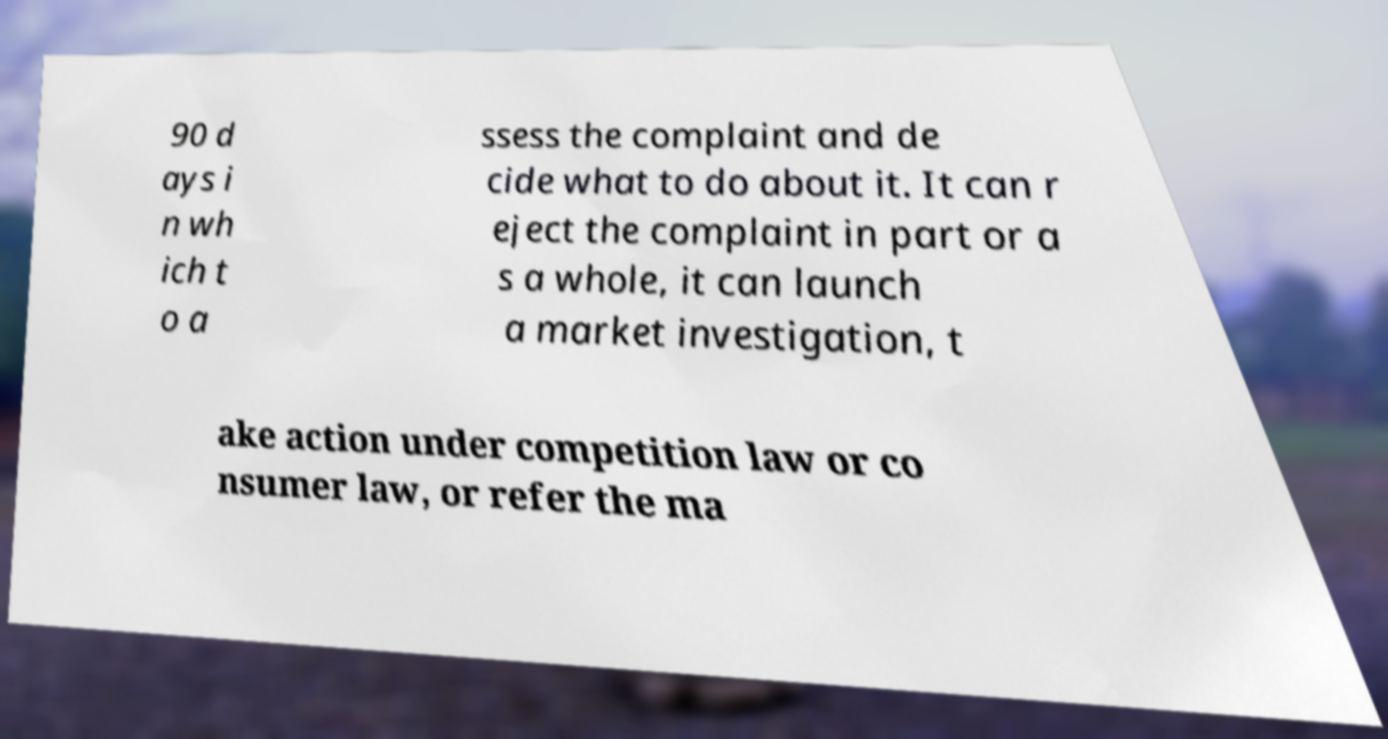There's text embedded in this image that I need extracted. Can you transcribe it verbatim? 90 d ays i n wh ich t o a ssess the complaint and de cide what to do about it. It can r eject the complaint in part or a s a whole, it can launch a market investigation, t ake action under competition law or co nsumer law, or refer the ma 